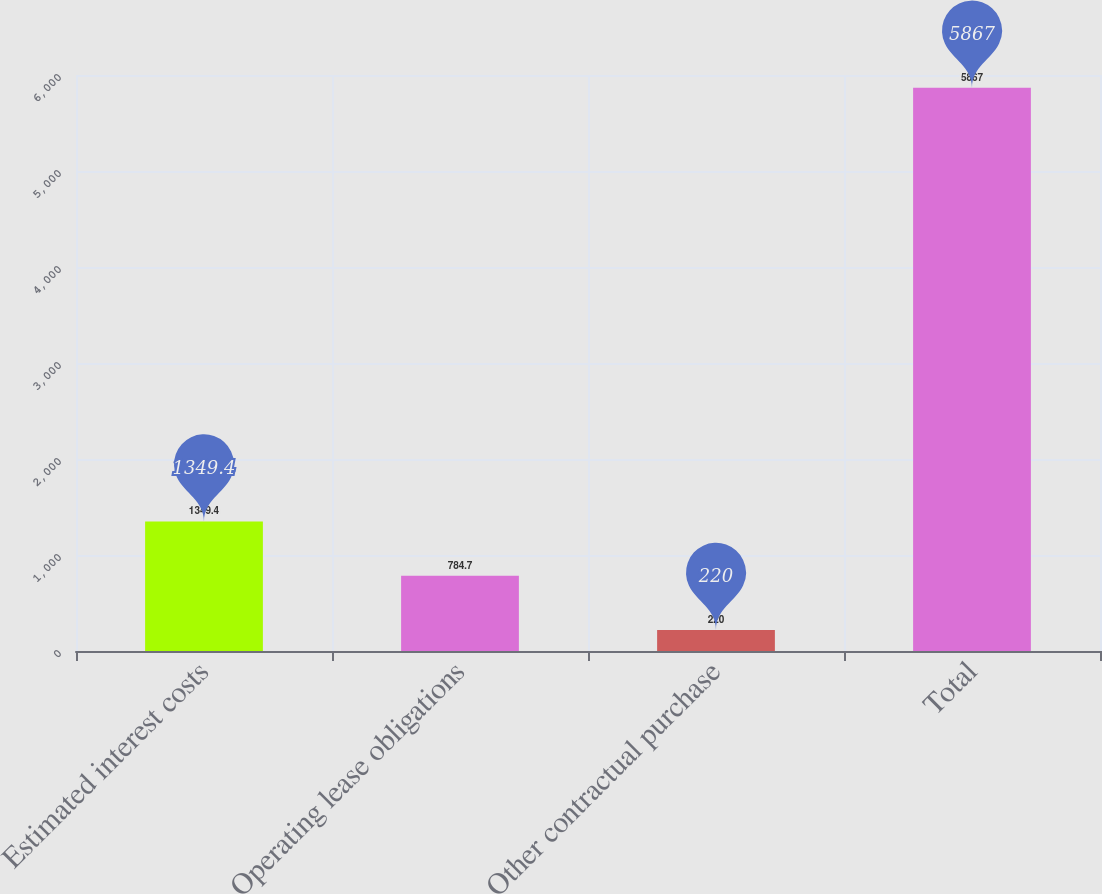Convert chart to OTSL. <chart><loc_0><loc_0><loc_500><loc_500><bar_chart><fcel>Estimated interest costs<fcel>Operating lease obligations<fcel>Other contractual purchase<fcel>Total<nl><fcel>1349.4<fcel>784.7<fcel>220<fcel>5867<nl></chart> 